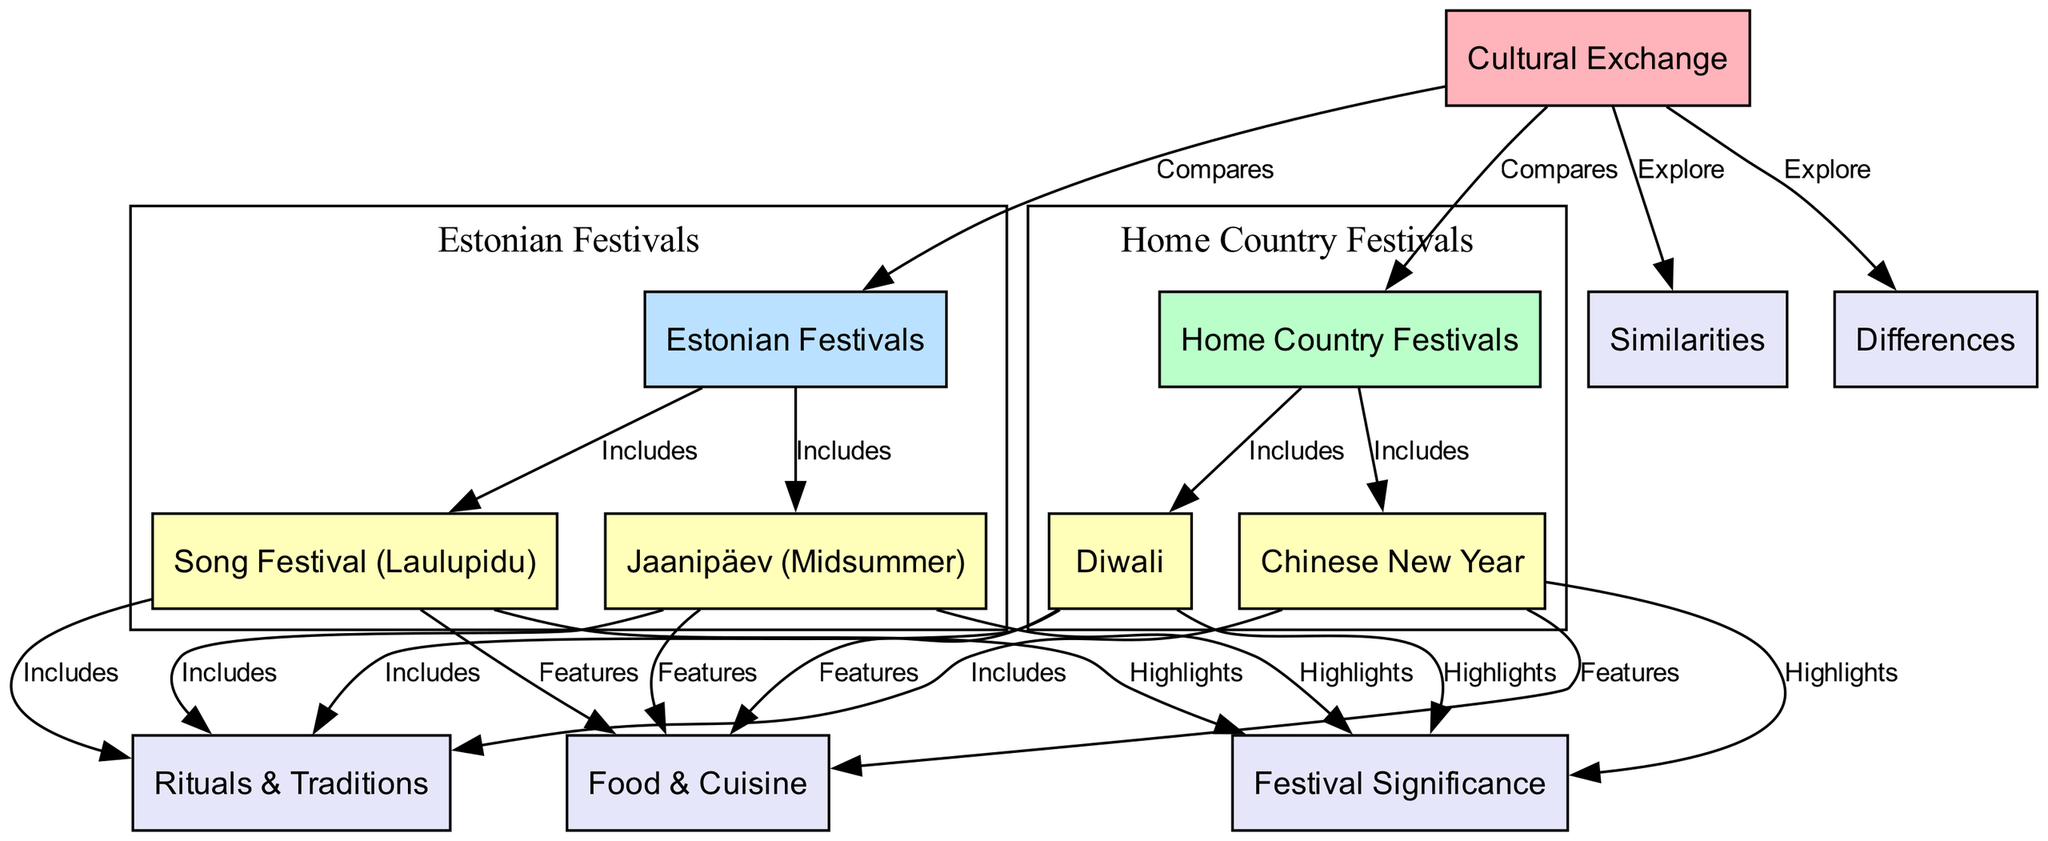What is the central theme of the diagram? The diagram's central theme is "Cultural Exchange," which is shown at the top as the main node and connects with other nodes representing festivals.
Answer: Cultural Exchange How many festivals are included under Home Country Festivals? The node "Home Country Festivals" is connected to two festival nodes: "Diwali" and "Chinese New Year," indicating that there are two festivals.
Answer: 2 What are the two included festivals in Estonia? The node "Estonian Festivals" connects to "Song Festival (Laulupidu)" and "Jaanipäev (Midsummer)," showing the two festivals from Estonia.
Answer: Song Festival (Laulupidu), Jaanipäev (Midsummer) Which aspect emphasizes the significance of "Diwali"? The diagram shows that "Diwali" highlights the aspect labeled "Festival Significance," indicating that this aspect is specifically associated with "Diwali."
Answer: Festival Significance What similarities are explored in the diagram? The diagram indicates that both "Home Country Festivals" and "Estonian Festivals" lead to a common node labeled "Similarities," hence similar aspects of festivals are explored.
Answer: Similarities Which aspect has the highest number of connections? Upon reviewing the connections, each festival has connections with "Festival Significance," "Rituals & Traditions," and "Food & Cuisine," but "Home Country Festivals" and "Estonian Festivals" lead to the "Explore" connections, indicating the focus on similarities and differences which implies many connections overall across nodes.
Answer: Explore List all aspects that connect to "Chinese New Year." The "Chinese New Year" festival connects to three aspects: "Festival Significance," "Rituals & Traditions," and "Food & Cuisine", as indicated by the edges from this festival node.
Answer: Festival Significance, Rituals & Traditions, Food & Cuisine What is the relationship type between "Cultural Exchange" and "Home Country Festivals"? The relationship is labeled as "Compares," showing the type of connection between the "Cultural Exchange" node and the "Home Country Festivals" node.
Answer: Compares How many edges connect "Jaanipäev (Midsummer)" to other nodes? "Jaanipäev (Midsummer)" connects to three aspects: "Festival Significance," "Rituals & Traditions," and "Food & Cuisine," leading to a total of three edges associated with it.
Answer: 3 